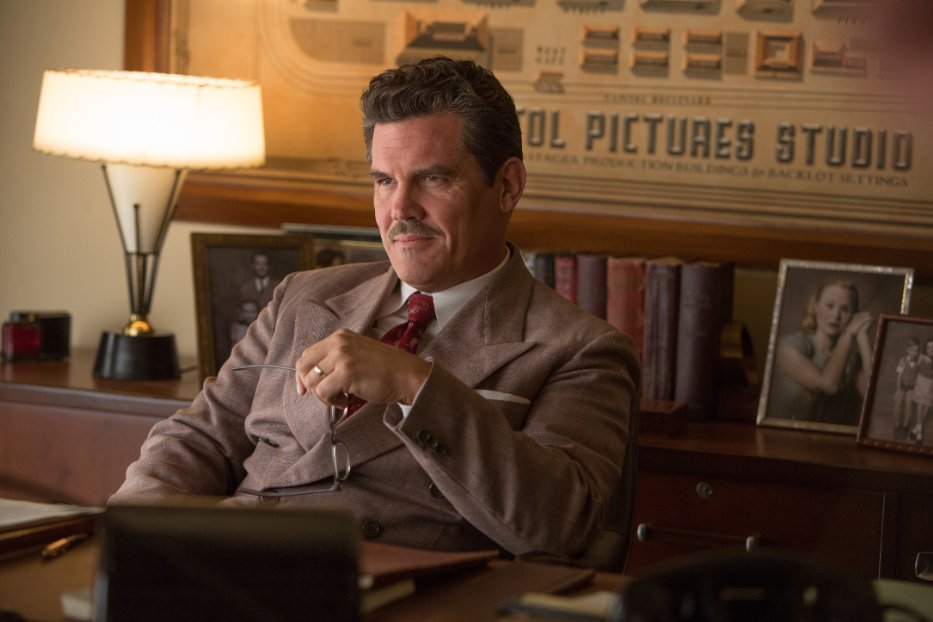Imagine a secret compartment hidden in the desk. What might it contain? Inside the secret compartment, one might find a collection of confidential documents detailing Hollywood scandals, undisclosed contracts, or sensitive information about major stars. Perhaps there’s also a diary revealing Eddie Mannix's personal thoughts, struggles, and insights into the hidden machinations of the film industry, showing the weight of his responsibilities and the secrets he keeps. 